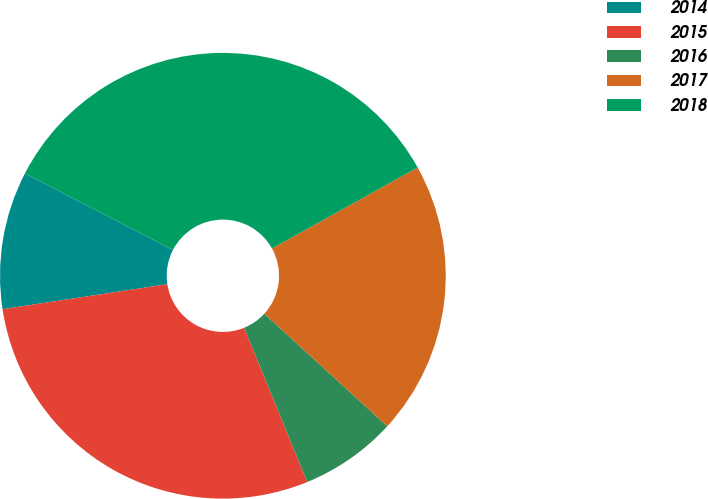<chart> <loc_0><loc_0><loc_500><loc_500><pie_chart><fcel>2014<fcel>2015<fcel>2016<fcel>2017<fcel>2018<nl><fcel>9.99%<fcel>28.78%<fcel>7.02%<fcel>19.87%<fcel>34.33%<nl></chart> 